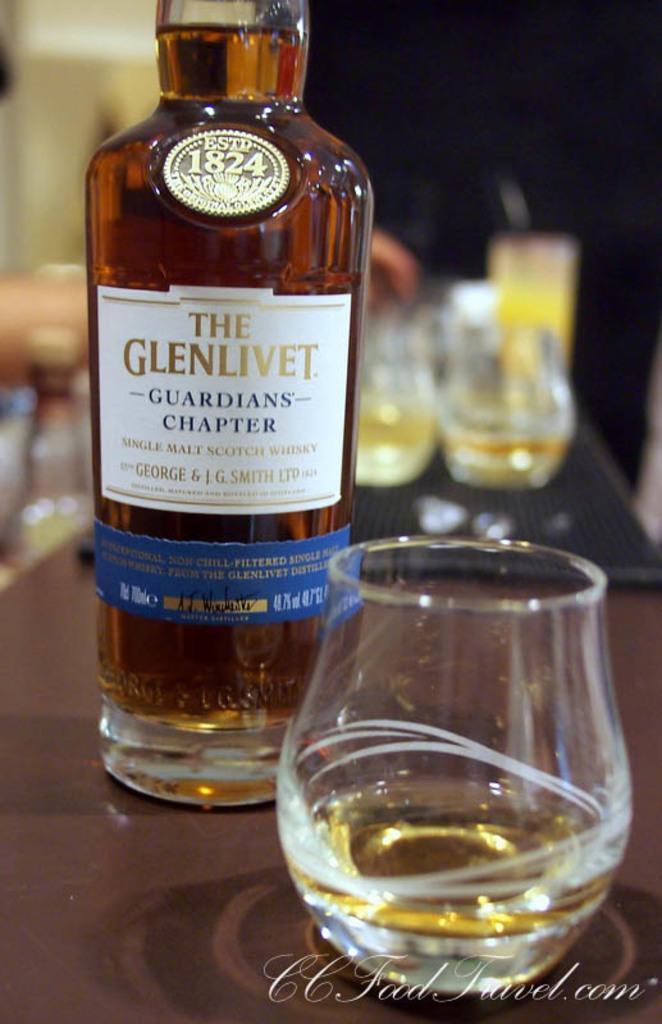<image>
Describe the image concisely. Bottle of alcohol with a sticker that says "The Glenlivet". 